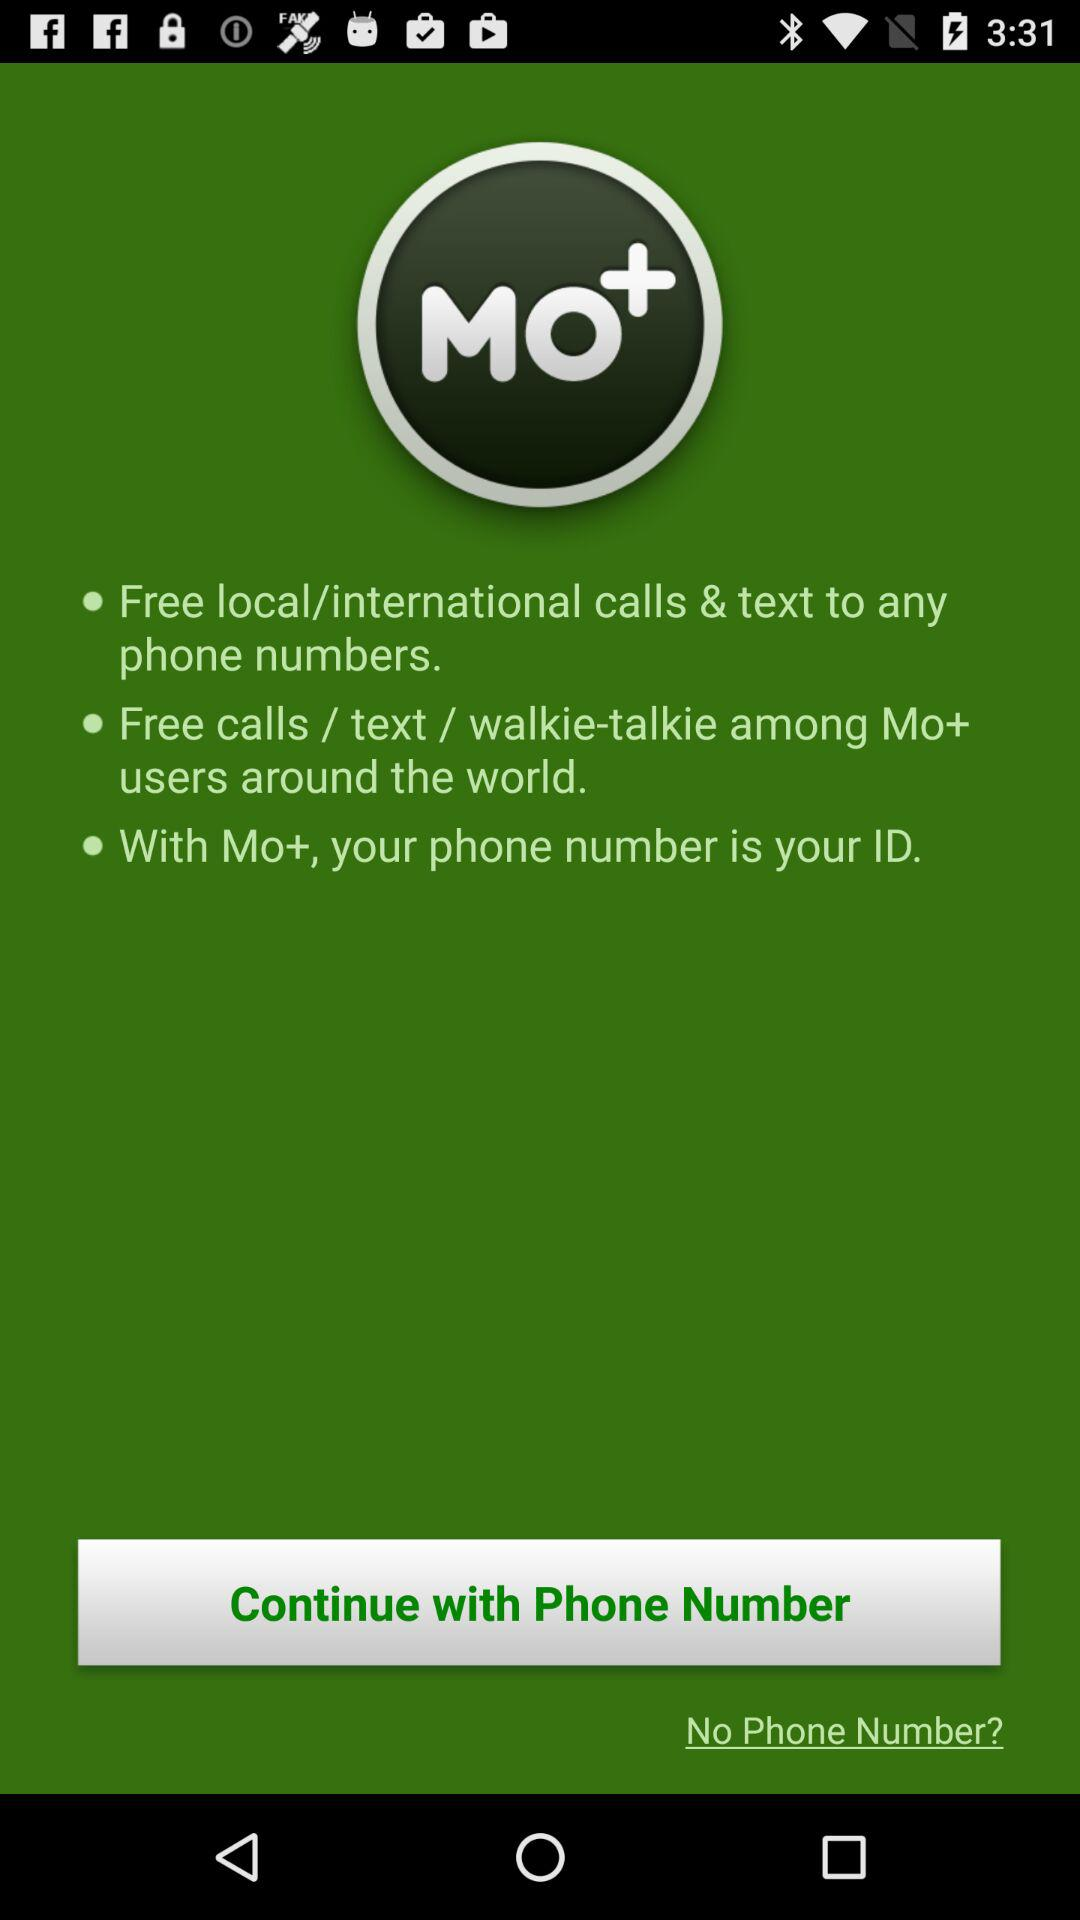What is the application name? The application name is "MO+". 